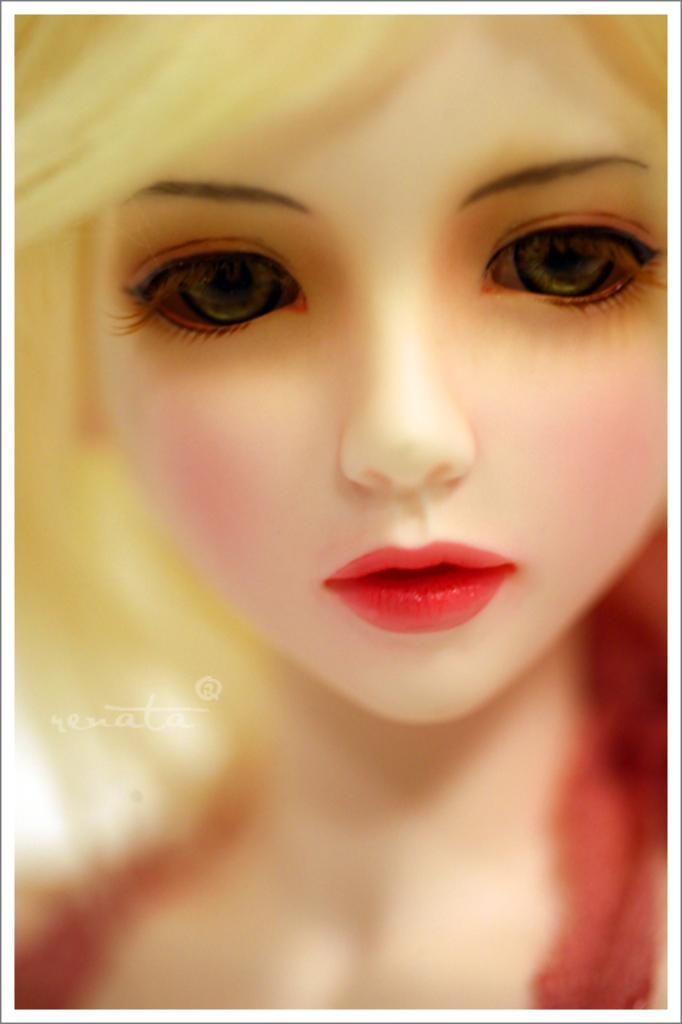What is the main subject of the image? There is a person's face in the image. Can you describe any additional elements in the image? There is a watermark on the left side of the image. What type of pollution can be seen in the image? There is no pollution visible in the image; it features a person's face and a watermark. Is there a ghost present in the image? There is no ghost present in the image; it features a person's face and a watermark. 